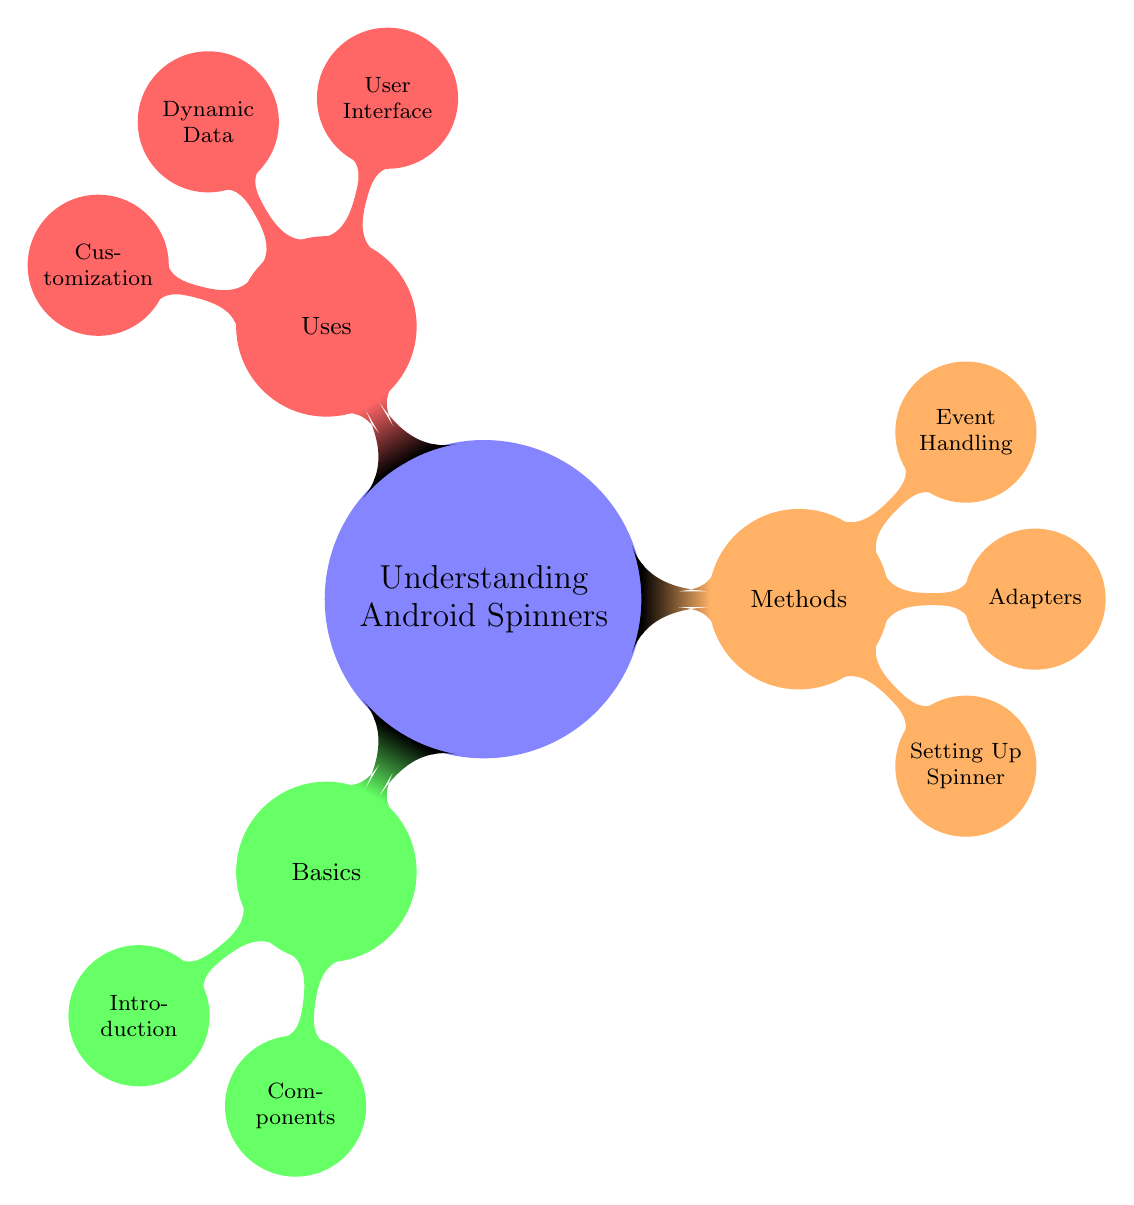What is the main topic of the mind map? The central node, which represents the overall theme of the diagram, is labeled "Understanding Android Spinners." This is the focus of the mind map and all other nodes branch out from it.
Answer: Understanding Android Spinners How many main subcategories are present in the diagram? The first level of child nodes, directly connected to the main topic, includes three subcategories: Basics, Methods, and Uses. Counting these nodes gives us a total of three main subcategories.
Answer: Three Which subcategory includes "Event Handling"? The node "Event Handling" is a child of the "Methods" subcategory. This means it falls under the methods used in relation to Android Spinners. The relationship can be traced from the main topic to the "Methods" node and then to "Event Handling."
Answer: Methods What are the names of the components listed under "Basics"? The subcategory "Components" contains two items: "Spinner" and "Adapter." These are the main components necessary for understanding the basics of Android Spinners. By identifying this node and reading its children, we can find the answer.
Answer: Spinner, Adapter What action does "onItemSelectedListener" correspond to? The "onItemSelectedListener" is associated with handling user selection in the event handling process of the Spinner. This can be gathered by connecting the "Event Handling" node to its description under it.
Answer: Handles user selection What type of adapter is used for customized item layout? The type of adapter that allows for a customized layout is labeled as "CustomAdapter." This node specifies the use case directly under the "Adapters" node. By locating this part of the diagram, the answer can be derived.
Answer: CustomAdapter How does the "Uses" category correspond to user interface design in apps? The "Uses" category highlights that Spinners are utilized in the user interface for purposes such as form inputs and filtering options. By examining the "User Interface" node within the "Uses" category, we can clearly see this relationship.
Answer: User Interface What kind of data source does "CursorAdapter" represent? "CursorAdapter" is specified to work with a database query cursor, which means it is used to bind data obtained from a database to the Spinner. By referring to the "Adapters" section of the diagram, this information can be extracted.
Answer: Database query cursor What appearance modifications can be made to a Spinner? Under the "Customization" portion of the "Uses" category, "Styling" refers to the changes that can be applied to the Spinner's appearance. This clearly indicates the flexibility in designing the visual aspects of the Spinner.
Answer: Styling 